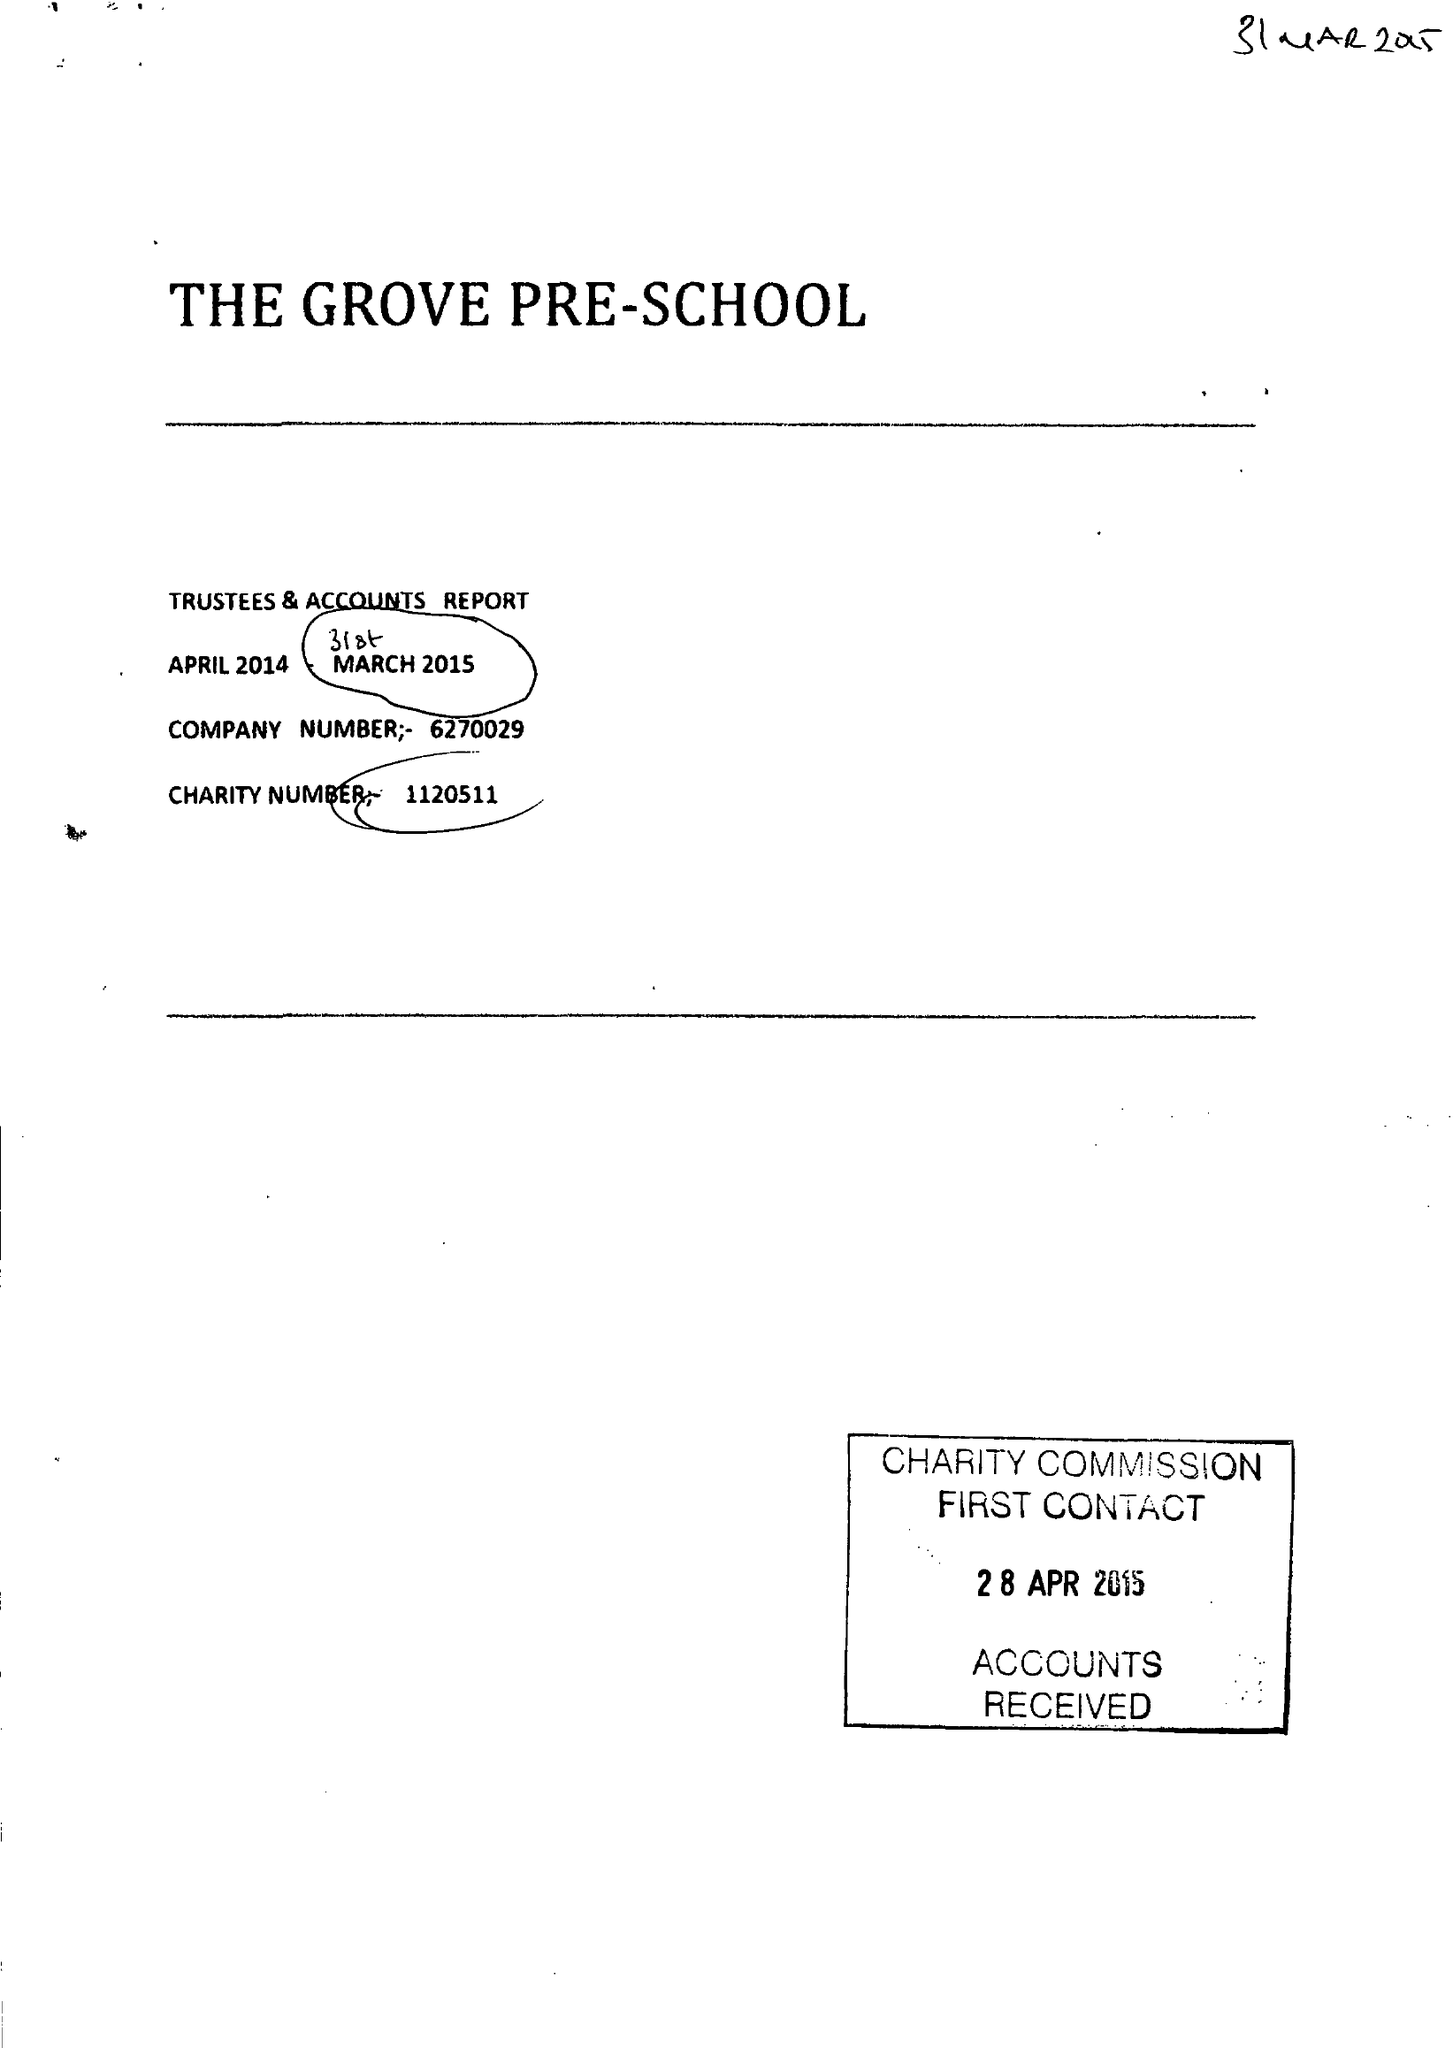What is the value for the address__street_line?
Answer the question using a single word or phrase. HARRAS BANK 